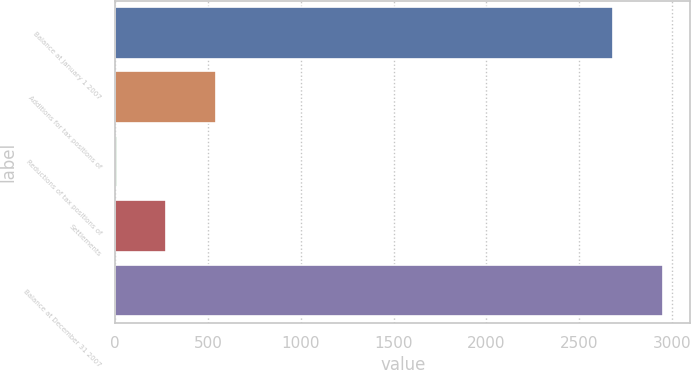Convert chart. <chart><loc_0><loc_0><loc_500><loc_500><bar_chart><fcel>Balance at January 1 2007<fcel>Additions for tax positions of<fcel>Reductions of tax positions of<fcel>Settlements<fcel>Balance at December 31 2007<nl><fcel>2685<fcel>542.6<fcel>7<fcel>274.8<fcel>2952.8<nl></chart> 